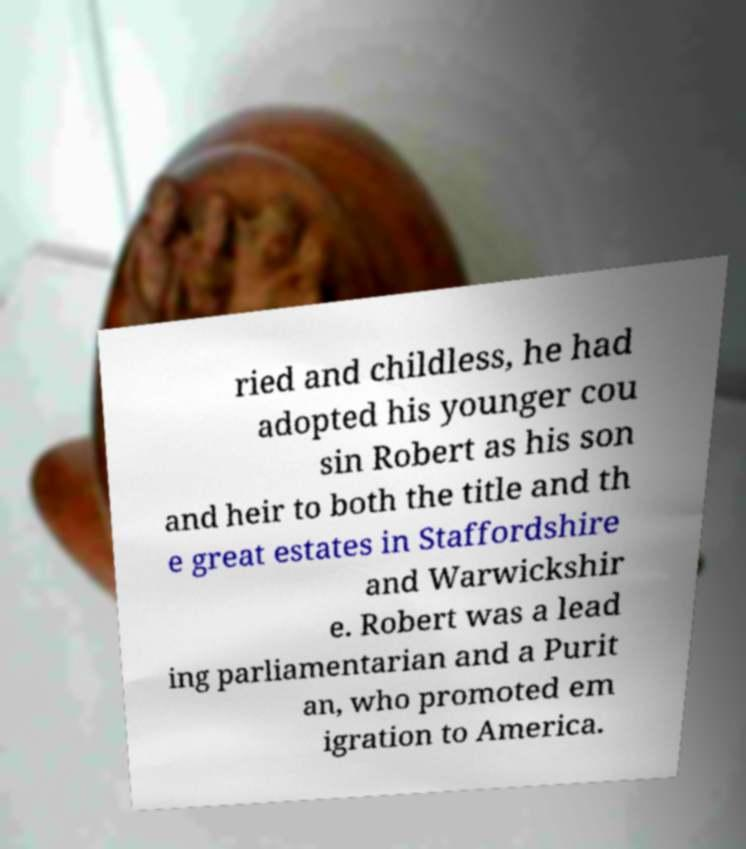There's text embedded in this image that I need extracted. Can you transcribe it verbatim? ried and childless, he had adopted his younger cou sin Robert as his son and heir to both the title and th e great estates in Staffordshire and Warwickshir e. Robert was a lead ing parliamentarian and a Purit an, who promoted em igration to America. 